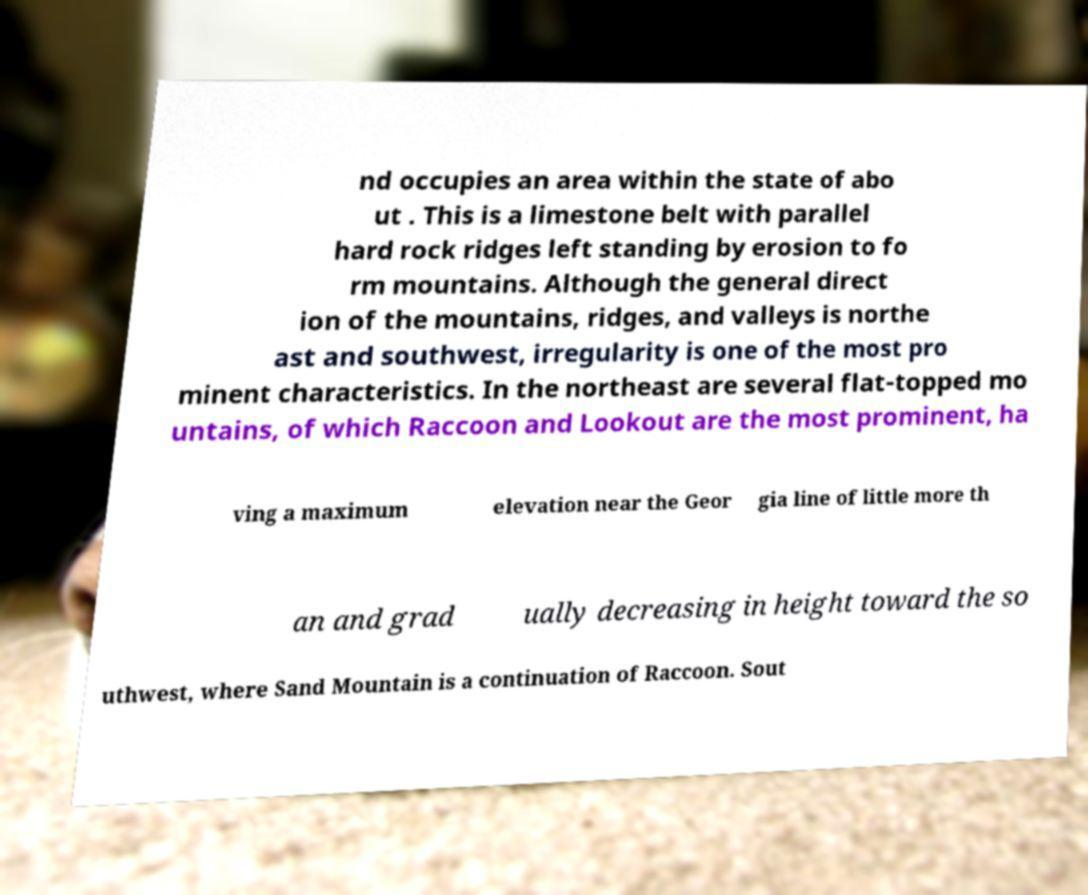Can you read and provide the text displayed in the image?This photo seems to have some interesting text. Can you extract and type it out for me? nd occupies an area within the state of abo ut . This is a limestone belt with parallel hard rock ridges left standing by erosion to fo rm mountains. Although the general direct ion of the mountains, ridges, and valleys is northe ast and southwest, irregularity is one of the most pro minent characteristics. In the northeast are several flat-topped mo untains, of which Raccoon and Lookout are the most prominent, ha ving a maximum elevation near the Geor gia line of little more th an and grad ually decreasing in height toward the so uthwest, where Sand Mountain is a continuation of Raccoon. Sout 